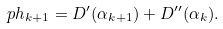Convert formula to latex. <formula><loc_0><loc_0><loc_500><loc_500>\ p h _ { k + 1 } = D ^ { \prime } ( \alpha _ { k + 1 } ) + D ^ { \prime \prime } ( \alpha _ { k } ) .</formula> 